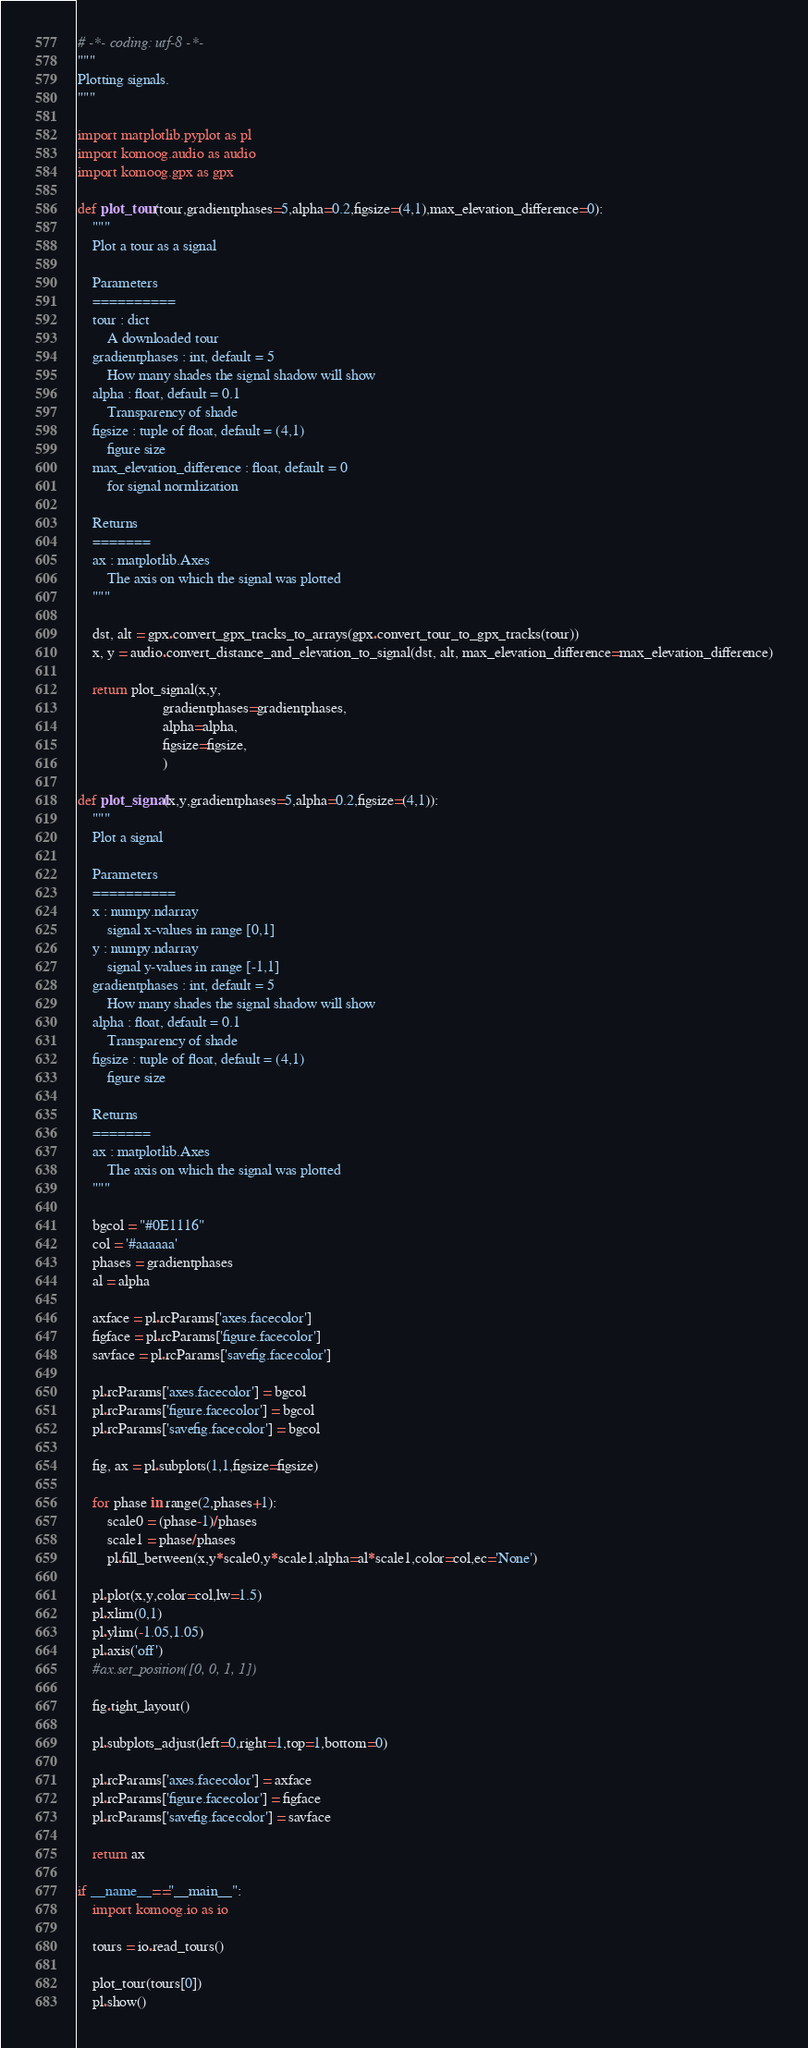Convert code to text. <code><loc_0><loc_0><loc_500><loc_500><_Python_># -*- coding: utf-8 -*-
"""
Plotting signals.
"""

import matplotlib.pyplot as pl
import komoog.audio as audio
import komoog.gpx as gpx

def plot_tour(tour,gradientphases=5,alpha=0.2,figsize=(4,1),max_elevation_difference=0):
    """
    Plot a tour as a signal

    Parameters
    ==========
    tour : dict
        A downloaded tour
    gradientphases : int, default = 5
        How many shades the signal shadow will show
    alpha : float, default = 0.1
        Transparency of shade
    figsize : tuple of float, default = (4,1)
        figure size
    max_elevation_difference : float, default = 0
        for signal normlization

    Returns
    =======
    ax : matplotlib.Axes
        The axis on which the signal was plotted
    """

    dst, alt = gpx.convert_gpx_tracks_to_arrays(gpx.convert_tour_to_gpx_tracks(tour))
    x, y = audio.convert_distance_and_elevation_to_signal(dst, alt, max_elevation_difference=max_elevation_difference)

    return plot_signal(x,y,
                       gradientphases=gradientphases,
                       alpha=alpha,
                       figsize=figsize,
                       )

def plot_signal(x,y,gradientphases=5,alpha=0.2,figsize=(4,1)):
    """
    Plot a signal

    Parameters
    ==========
    x : numpy.ndarray
        signal x-values in range [0,1]
    y : numpy.ndarray
        signal y-values in range [-1,1]
    gradientphases : int, default = 5
        How many shades the signal shadow will show
    alpha : float, default = 0.1
        Transparency of shade
    figsize : tuple of float, default = (4,1)
        figure size

    Returns
    =======
    ax : matplotlib.Axes
        The axis on which the signal was plotted
    """

    bgcol = "#0E1116"
    col = '#aaaaaa'
    phases = gradientphases
    al = alpha

    axface = pl.rcParams['axes.facecolor']
    figface = pl.rcParams['figure.facecolor']
    savface = pl.rcParams['savefig.facecolor']

    pl.rcParams['axes.facecolor'] = bgcol
    pl.rcParams['figure.facecolor'] = bgcol
    pl.rcParams['savefig.facecolor'] = bgcol

    fig, ax = pl.subplots(1,1,figsize=figsize)

    for phase in range(2,phases+1):
        scale0 = (phase-1)/phases
        scale1 = phase/phases
        pl.fill_between(x,y*scale0,y*scale1,alpha=al*scale1,color=col,ec='None')

    pl.plot(x,y,color=col,lw=1.5)
    pl.xlim(0,1)
    pl.ylim(-1.05,1.05)
    pl.axis('off')
    #ax.set_position([0, 0, 1, 1])

    fig.tight_layout()

    pl.subplots_adjust(left=0,right=1,top=1,bottom=0)

    pl.rcParams['axes.facecolor'] = axface
    pl.rcParams['figure.facecolor'] = figface
    pl.rcParams['savefig.facecolor'] = savface

    return ax

if __name__=="__main__":
    import komoog.io as io

    tours = io.read_tours()

    plot_tour(tours[0])
    pl.show()
</code> 